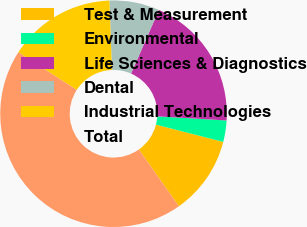Convert chart to OTSL. <chart><loc_0><loc_0><loc_500><loc_500><pie_chart><fcel>Test & Measurement<fcel>Environmental<fcel>Life Sciences & Diagnostics<fcel>Dental<fcel>Industrial Technologies<fcel>Total<nl><fcel>11.22%<fcel>3.05%<fcel>19.39%<fcel>7.13%<fcel>15.3%<fcel>43.91%<nl></chart> 